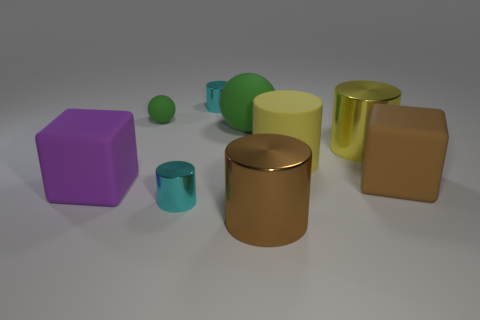Are there an equal number of purple things behind the brown metal cylinder and small matte balls?
Keep it short and to the point. Yes. The large thing that is the same shape as the small rubber object is what color?
Give a very brief answer. Green. What number of other metal objects have the same shape as the tiny green thing?
Provide a succinct answer. 0. There is a object that is the same color as the rubber cylinder; what is its material?
Offer a terse response. Metal. What number of tiny yellow cylinders are there?
Ensure brevity in your answer.  0. Is there a gray thing that has the same material as the purple cube?
Your response must be concise. No. What size is the other cylinder that is the same color as the rubber cylinder?
Provide a succinct answer. Large. Do the brown thing that is behind the large purple block and the cyan metallic object behind the purple cube have the same size?
Keep it short and to the point. No. What is the size of the purple rubber block to the left of the large brown matte thing?
Offer a terse response. Large. Is there another rubber object that has the same color as the small matte object?
Offer a very short reply. Yes. 